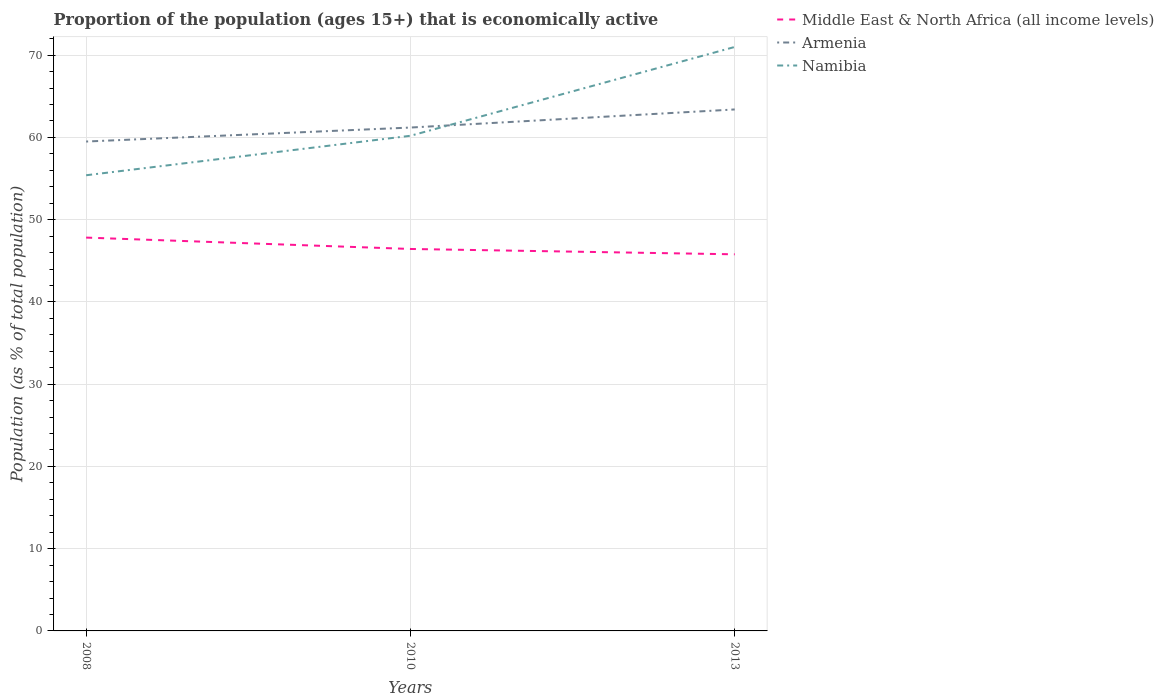How many different coloured lines are there?
Keep it short and to the point. 3. Across all years, what is the maximum proportion of the population that is economically active in Armenia?
Give a very brief answer. 59.5. What is the total proportion of the population that is economically active in Middle East & North Africa (all income levels) in the graph?
Keep it short and to the point. 0.65. What is the difference between the highest and the second highest proportion of the population that is economically active in Middle East & North Africa (all income levels)?
Offer a very short reply. 2.03. Is the proportion of the population that is economically active in Armenia strictly greater than the proportion of the population that is economically active in Middle East & North Africa (all income levels) over the years?
Provide a succinct answer. No. What is the difference between two consecutive major ticks on the Y-axis?
Your response must be concise. 10. Does the graph contain grids?
Your response must be concise. Yes. How many legend labels are there?
Keep it short and to the point. 3. How are the legend labels stacked?
Offer a terse response. Vertical. What is the title of the graph?
Make the answer very short. Proportion of the population (ages 15+) that is economically active. Does "French Polynesia" appear as one of the legend labels in the graph?
Provide a succinct answer. No. What is the label or title of the Y-axis?
Your response must be concise. Population (as % of total population). What is the Population (as % of total population) of Middle East & North Africa (all income levels) in 2008?
Offer a very short reply. 47.82. What is the Population (as % of total population) of Armenia in 2008?
Give a very brief answer. 59.5. What is the Population (as % of total population) of Namibia in 2008?
Ensure brevity in your answer.  55.4. What is the Population (as % of total population) of Middle East & North Africa (all income levels) in 2010?
Your answer should be compact. 46.44. What is the Population (as % of total population) of Armenia in 2010?
Offer a terse response. 61.2. What is the Population (as % of total population) in Namibia in 2010?
Offer a terse response. 60.2. What is the Population (as % of total population) of Middle East & North Africa (all income levels) in 2013?
Offer a very short reply. 45.79. What is the Population (as % of total population) of Armenia in 2013?
Provide a short and direct response. 63.4. What is the Population (as % of total population) of Namibia in 2013?
Offer a terse response. 71. Across all years, what is the maximum Population (as % of total population) of Middle East & North Africa (all income levels)?
Your response must be concise. 47.82. Across all years, what is the maximum Population (as % of total population) of Armenia?
Your answer should be very brief. 63.4. Across all years, what is the minimum Population (as % of total population) in Middle East & North Africa (all income levels)?
Your answer should be very brief. 45.79. Across all years, what is the minimum Population (as % of total population) in Armenia?
Your answer should be very brief. 59.5. Across all years, what is the minimum Population (as % of total population) of Namibia?
Provide a succinct answer. 55.4. What is the total Population (as % of total population) in Middle East & North Africa (all income levels) in the graph?
Provide a short and direct response. 140.05. What is the total Population (as % of total population) of Armenia in the graph?
Your answer should be very brief. 184.1. What is the total Population (as % of total population) in Namibia in the graph?
Ensure brevity in your answer.  186.6. What is the difference between the Population (as % of total population) in Middle East & North Africa (all income levels) in 2008 and that in 2010?
Your answer should be very brief. 1.38. What is the difference between the Population (as % of total population) in Armenia in 2008 and that in 2010?
Make the answer very short. -1.7. What is the difference between the Population (as % of total population) in Middle East & North Africa (all income levels) in 2008 and that in 2013?
Provide a succinct answer. 2.03. What is the difference between the Population (as % of total population) in Namibia in 2008 and that in 2013?
Make the answer very short. -15.6. What is the difference between the Population (as % of total population) in Middle East & North Africa (all income levels) in 2010 and that in 2013?
Your response must be concise. 0.65. What is the difference between the Population (as % of total population) of Armenia in 2010 and that in 2013?
Ensure brevity in your answer.  -2.2. What is the difference between the Population (as % of total population) of Middle East & North Africa (all income levels) in 2008 and the Population (as % of total population) of Armenia in 2010?
Give a very brief answer. -13.38. What is the difference between the Population (as % of total population) in Middle East & North Africa (all income levels) in 2008 and the Population (as % of total population) in Namibia in 2010?
Your response must be concise. -12.38. What is the difference between the Population (as % of total population) in Armenia in 2008 and the Population (as % of total population) in Namibia in 2010?
Provide a short and direct response. -0.7. What is the difference between the Population (as % of total population) in Middle East & North Africa (all income levels) in 2008 and the Population (as % of total population) in Armenia in 2013?
Your answer should be very brief. -15.58. What is the difference between the Population (as % of total population) in Middle East & North Africa (all income levels) in 2008 and the Population (as % of total population) in Namibia in 2013?
Offer a very short reply. -23.18. What is the difference between the Population (as % of total population) of Armenia in 2008 and the Population (as % of total population) of Namibia in 2013?
Your answer should be compact. -11.5. What is the difference between the Population (as % of total population) in Middle East & North Africa (all income levels) in 2010 and the Population (as % of total population) in Armenia in 2013?
Make the answer very short. -16.96. What is the difference between the Population (as % of total population) in Middle East & North Africa (all income levels) in 2010 and the Population (as % of total population) in Namibia in 2013?
Your answer should be very brief. -24.56. What is the difference between the Population (as % of total population) in Armenia in 2010 and the Population (as % of total population) in Namibia in 2013?
Your answer should be compact. -9.8. What is the average Population (as % of total population) in Middle East & North Africa (all income levels) per year?
Give a very brief answer. 46.68. What is the average Population (as % of total population) of Armenia per year?
Give a very brief answer. 61.37. What is the average Population (as % of total population) of Namibia per year?
Make the answer very short. 62.2. In the year 2008, what is the difference between the Population (as % of total population) of Middle East & North Africa (all income levels) and Population (as % of total population) of Armenia?
Your response must be concise. -11.68. In the year 2008, what is the difference between the Population (as % of total population) of Middle East & North Africa (all income levels) and Population (as % of total population) of Namibia?
Make the answer very short. -7.58. In the year 2008, what is the difference between the Population (as % of total population) in Armenia and Population (as % of total population) in Namibia?
Your answer should be compact. 4.1. In the year 2010, what is the difference between the Population (as % of total population) of Middle East & North Africa (all income levels) and Population (as % of total population) of Armenia?
Your answer should be very brief. -14.76. In the year 2010, what is the difference between the Population (as % of total population) in Middle East & North Africa (all income levels) and Population (as % of total population) in Namibia?
Your response must be concise. -13.76. In the year 2010, what is the difference between the Population (as % of total population) in Armenia and Population (as % of total population) in Namibia?
Your response must be concise. 1. In the year 2013, what is the difference between the Population (as % of total population) in Middle East & North Africa (all income levels) and Population (as % of total population) in Armenia?
Give a very brief answer. -17.61. In the year 2013, what is the difference between the Population (as % of total population) in Middle East & North Africa (all income levels) and Population (as % of total population) in Namibia?
Your answer should be compact. -25.21. What is the ratio of the Population (as % of total population) in Middle East & North Africa (all income levels) in 2008 to that in 2010?
Keep it short and to the point. 1.03. What is the ratio of the Population (as % of total population) in Armenia in 2008 to that in 2010?
Provide a succinct answer. 0.97. What is the ratio of the Population (as % of total population) in Namibia in 2008 to that in 2010?
Ensure brevity in your answer.  0.92. What is the ratio of the Population (as % of total population) in Middle East & North Africa (all income levels) in 2008 to that in 2013?
Keep it short and to the point. 1.04. What is the ratio of the Population (as % of total population) in Armenia in 2008 to that in 2013?
Provide a succinct answer. 0.94. What is the ratio of the Population (as % of total population) in Namibia in 2008 to that in 2013?
Your response must be concise. 0.78. What is the ratio of the Population (as % of total population) in Middle East & North Africa (all income levels) in 2010 to that in 2013?
Provide a short and direct response. 1.01. What is the ratio of the Population (as % of total population) of Armenia in 2010 to that in 2013?
Make the answer very short. 0.97. What is the ratio of the Population (as % of total population) in Namibia in 2010 to that in 2013?
Provide a succinct answer. 0.85. What is the difference between the highest and the second highest Population (as % of total population) of Middle East & North Africa (all income levels)?
Ensure brevity in your answer.  1.38. What is the difference between the highest and the lowest Population (as % of total population) of Middle East & North Africa (all income levels)?
Your response must be concise. 2.03. What is the difference between the highest and the lowest Population (as % of total population) in Armenia?
Offer a terse response. 3.9. What is the difference between the highest and the lowest Population (as % of total population) of Namibia?
Offer a terse response. 15.6. 